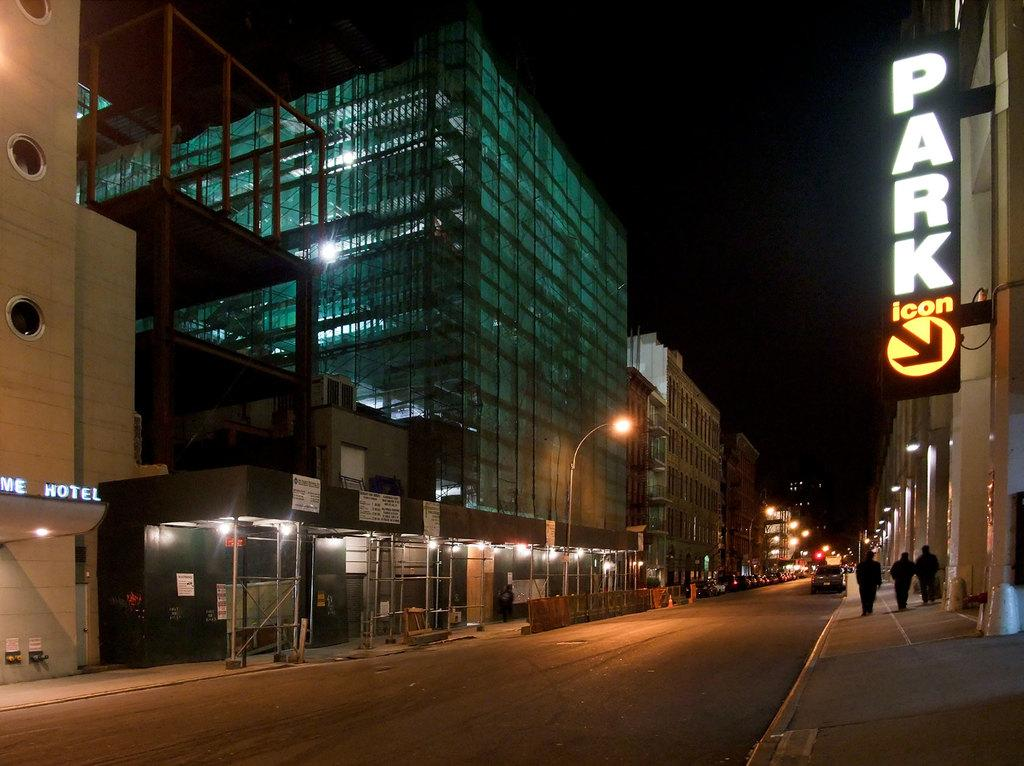Who or what can be seen in the image? There are people in the image. What is on the road in the image? There is a car on the road in the image. What can be seen illuminated in the image? There are lights visible in the image. What objects are present in the image that are not related to people or vehicles? There are boards and poles in the image. What type of structures are visible in the image? There are buildings in the image. How would you describe the overall lighting conditions in the image? The background of the image is dark, but lights are visible in the background. What type of suit is the deer wearing in the image? There is no deer or suit present in the image. How does the cough of the person in the image affect their ability to communicate with others? There is no mention of a cough or communication in the image. 